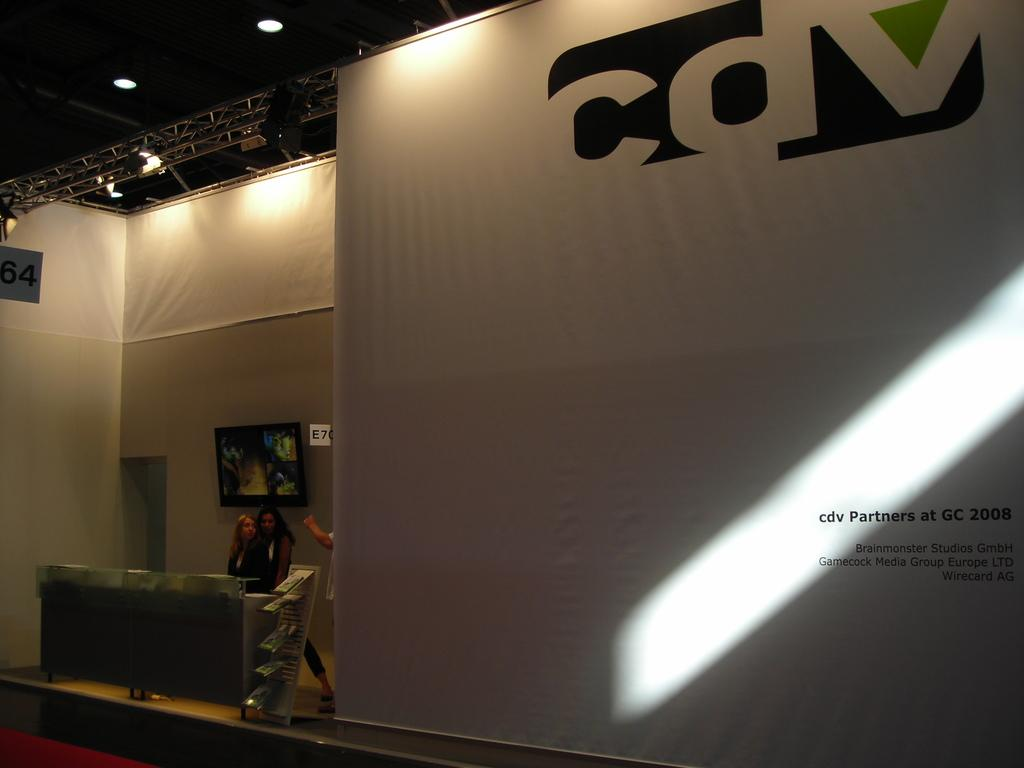<image>
Give a short and clear explanation of the subsequent image. the letters cdv are on the white wall 